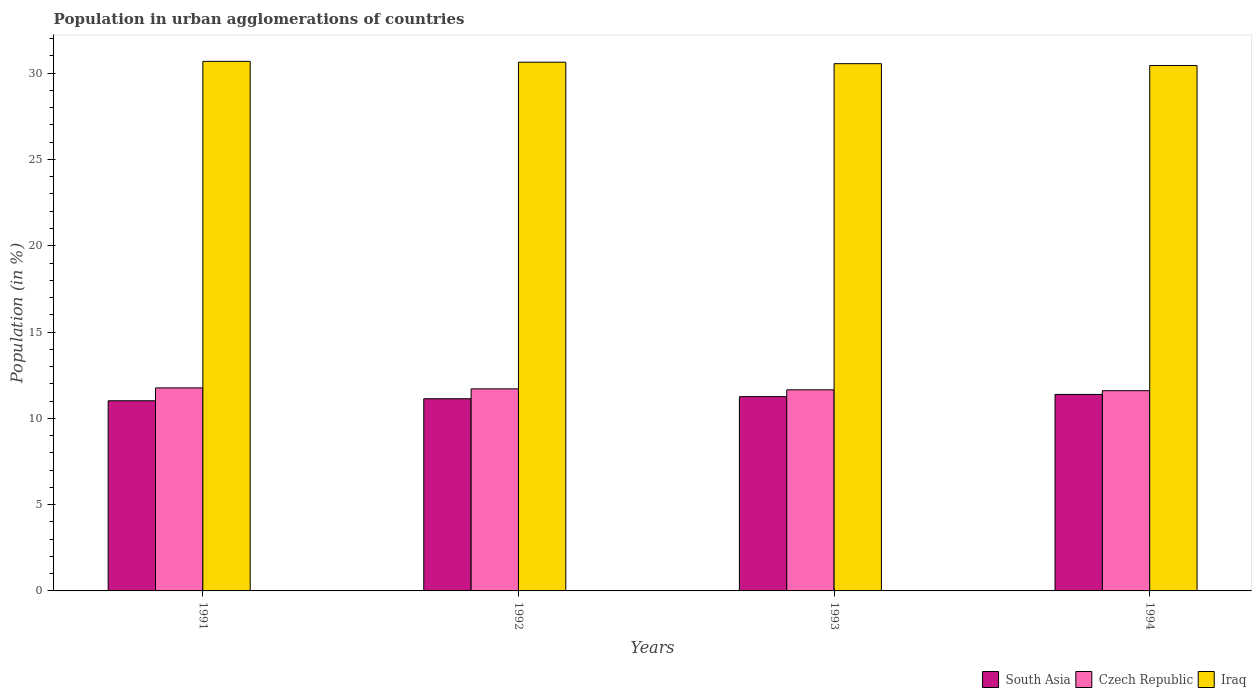How many different coloured bars are there?
Give a very brief answer. 3. How many groups of bars are there?
Offer a terse response. 4. Are the number of bars on each tick of the X-axis equal?
Give a very brief answer. Yes. How many bars are there on the 3rd tick from the right?
Your answer should be compact. 3. What is the percentage of population in urban agglomerations in Czech Republic in 1994?
Keep it short and to the point. 11.6. Across all years, what is the maximum percentage of population in urban agglomerations in Iraq?
Your answer should be compact. 30.68. Across all years, what is the minimum percentage of population in urban agglomerations in Iraq?
Provide a short and direct response. 30.44. In which year was the percentage of population in urban agglomerations in Czech Republic maximum?
Offer a terse response. 1991. In which year was the percentage of population in urban agglomerations in Iraq minimum?
Offer a terse response. 1994. What is the total percentage of population in urban agglomerations in Czech Republic in the graph?
Provide a succinct answer. 46.72. What is the difference between the percentage of population in urban agglomerations in South Asia in 1993 and that in 1994?
Make the answer very short. -0.13. What is the difference between the percentage of population in urban agglomerations in South Asia in 1993 and the percentage of population in urban agglomerations in Iraq in 1994?
Offer a terse response. -19.19. What is the average percentage of population in urban agglomerations in Czech Republic per year?
Ensure brevity in your answer.  11.68. In the year 1994, what is the difference between the percentage of population in urban agglomerations in South Asia and percentage of population in urban agglomerations in Iraq?
Offer a very short reply. -19.06. What is the ratio of the percentage of population in urban agglomerations in Iraq in 1991 to that in 1992?
Your answer should be very brief. 1. Is the percentage of population in urban agglomerations in South Asia in 1993 less than that in 1994?
Your response must be concise. Yes. What is the difference between the highest and the second highest percentage of population in urban agglomerations in South Asia?
Ensure brevity in your answer.  0.13. What is the difference between the highest and the lowest percentage of population in urban agglomerations in South Asia?
Your response must be concise. 0.37. In how many years, is the percentage of population in urban agglomerations in Iraq greater than the average percentage of population in urban agglomerations in Iraq taken over all years?
Keep it short and to the point. 2. What does the 3rd bar from the left in 1993 represents?
Offer a very short reply. Iraq. What does the 1st bar from the right in 1991 represents?
Your response must be concise. Iraq. Is it the case that in every year, the sum of the percentage of population in urban agglomerations in Iraq and percentage of population in urban agglomerations in Czech Republic is greater than the percentage of population in urban agglomerations in South Asia?
Provide a short and direct response. Yes. How many bars are there?
Ensure brevity in your answer.  12. Are all the bars in the graph horizontal?
Your answer should be compact. No. What is the difference between two consecutive major ticks on the Y-axis?
Your response must be concise. 5. Are the values on the major ticks of Y-axis written in scientific E-notation?
Keep it short and to the point. No. Does the graph contain grids?
Keep it short and to the point. No. Where does the legend appear in the graph?
Offer a terse response. Bottom right. How are the legend labels stacked?
Keep it short and to the point. Horizontal. What is the title of the graph?
Keep it short and to the point. Population in urban agglomerations of countries. Does "United Kingdom" appear as one of the legend labels in the graph?
Offer a very short reply. No. What is the label or title of the X-axis?
Ensure brevity in your answer.  Years. What is the label or title of the Y-axis?
Offer a very short reply. Population (in %). What is the Population (in %) of South Asia in 1991?
Offer a very short reply. 11.02. What is the Population (in %) in Czech Republic in 1991?
Provide a succinct answer. 11.76. What is the Population (in %) in Iraq in 1991?
Your response must be concise. 30.68. What is the Population (in %) of South Asia in 1992?
Your answer should be very brief. 11.13. What is the Population (in %) of Czech Republic in 1992?
Ensure brevity in your answer.  11.71. What is the Population (in %) in Iraq in 1992?
Give a very brief answer. 30.64. What is the Population (in %) in South Asia in 1993?
Offer a very short reply. 11.26. What is the Population (in %) of Czech Republic in 1993?
Provide a short and direct response. 11.65. What is the Population (in %) of Iraq in 1993?
Your answer should be very brief. 30.55. What is the Population (in %) of South Asia in 1994?
Offer a terse response. 11.39. What is the Population (in %) of Czech Republic in 1994?
Your response must be concise. 11.6. What is the Population (in %) of Iraq in 1994?
Keep it short and to the point. 30.44. Across all years, what is the maximum Population (in %) of South Asia?
Offer a terse response. 11.39. Across all years, what is the maximum Population (in %) in Czech Republic?
Offer a terse response. 11.76. Across all years, what is the maximum Population (in %) in Iraq?
Your answer should be compact. 30.68. Across all years, what is the minimum Population (in %) of South Asia?
Provide a short and direct response. 11.02. Across all years, what is the minimum Population (in %) in Czech Republic?
Your answer should be compact. 11.6. Across all years, what is the minimum Population (in %) of Iraq?
Offer a very short reply. 30.44. What is the total Population (in %) of South Asia in the graph?
Offer a terse response. 44.8. What is the total Population (in %) in Czech Republic in the graph?
Give a very brief answer. 46.72. What is the total Population (in %) of Iraq in the graph?
Your answer should be compact. 122.31. What is the difference between the Population (in %) in South Asia in 1991 and that in 1992?
Give a very brief answer. -0.12. What is the difference between the Population (in %) in Czech Republic in 1991 and that in 1992?
Offer a very short reply. 0.06. What is the difference between the Population (in %) of Iraq in 1991 and that in 1992?
Ensure brevity in your answer.  0.05. What is the difference between the Population (in %) of South Asia in 1991 and that in 1993?
Make the answer very short. -0.24. What is the difference between the Population (in %) in Czech Republic in 1991 and that in 1993?
Your answer should be very brief. 0.11. What is the difference between the Population (in %) of Iraq in 1991 and that in 1993?
Offer a terse response. 0.13. What is the difference between the Population (in %) of South Asia in 1991 and that in 1994?
Keep it short and to the point. -0.37. What is the difference between the Population (in %) of Czech Republic in 1991 and that in 1994?
Ensure brevity in your answer.  0.16. What is the difference between the Population (in %) in Iraq in 1991 and that in 1994?
Offer a terse response. 0.24. What is the difference between the Population (in %) of South Asia in 1992 and that in 1993?
Provide a short and direct response. -0.12. What is the difference between the Population (in %) in Czech Republic in 1992 and that in 1993?
Offer a terse response. 0.06. What is the difference between the Population (in %) in Iraq in 1992 and that in 1993?
Offer a very short reply. 0.09. What is the difference between the Population (in %) of South Asia in 1992 and that in 1994?
Provide a short and direct response. -0.25. What is the difference between the Population (in %) in Czech Republic in 1992 and that in 1994?
Ensure brevity in your answer.  0.1. What is the difference between the Population (in %) in Iraq in 1992 and that in 1994?
Provide a succinct answer. 0.19. What is the difference between the Population (in %) of South Asia in 1993 and that in 1994?
Your answer should be compact. -0.13. What is the difference between the Population (in %) in Czech Republic in 1993 and that in 1994?
Keep it short and to the point. 0.05. What is the difference between the Population (in %) of Iraq in 1993 and that in 1994?
Make the answer very short. 0.11. What is the difference between the Population (in %) in South Asia in 1991 and the Population (in %) in Czech Republic in 1992?
Keep it short and to the point. -0.69. What is the difference between the Population (in %) of South Asia in 1991 and the Population (in %) of Iraq in 1992?
Give a very brief answer. -19.62. What is the difference between the Population (in %) in Czech Republic in 1991 and the Population (in %) in Iraq in 1992?
Provide a succinct answer. -18.87. What is the difference between the Population (in %) in South Asia in 1991 and the Population (in %) in Czech Republic in 1993?
Provide a succinct answer. -0.63. What is the difference between the Population (in %) of South Asia in 1991 and the Population (in %) of Iraq in 1993?
Provide a short and direct response. -19.53. What is the difference between the Population (in %) in Czech Republic in 1991 and the Population (in %) in Iraq in 1993?
Offer a terse response. -18.79. What is the difference between the Population (in %) in South Asia in 1991 and the Population (in %) in Czech Republic in 1994?
Offer a very short reply. -0.58. What is the difference between the Population (in %) in South Asia in 1991 and the Population (in %) in Iraq in 1994?
Keep it short and to the point. -19.42. What is the difference between the Population (in %) in Czech Republic in 1991 and the Population (in %) in Iraq in 1994?
Ensure brevity in your answer.  -18.68. What is the difference between the Population (in %) of South Asia in 1992 and the Population (in %) of Czech Republic in 1993?
Keep it short and to the point. -0.52. What is the difference between the Population (in %) in South Asia in 1992 and the Population (in %) in Iraq in 1993?
Provide a short and direct response. -19.41. What is the difference between the Population (in %) of Czech Republic in 1992 and the Population (in %) of Iraq in 1993?
Provide a succinct answer. -18.84. What is the difference between the Population (in %) in South Asia in 1992 and the Population (in %) in Czech Republic in 1994?
Keep it short and to the point. -0.47. What is the difference between the Population (in %) in South Asia in 1992 and the Population (in %) in Iraq in 1994?
Offer a terse response. -19.31. What is the difference between the Population (in %) in Czech Republic in 1992 and the Population (in %) in Iraq in 1994?
Give a very brief answer. -18.73. What is the difference between the Population (in %) in South Asia in 1993 and the Population (in %) in Czech Republic in 1994?
Ensure brevity in your answer.  -0.35. What is the difference between the Population (in %) of South Asia in 1993 and the Population (in %) of Iraq in 1994?
Make the answer very short. -19.19. What is the difference between the Population (in %) of Czech Republic in 1993 and the Population (in %) of Iraq in 1994?
Provide a short and direct response. -18.79. What is the average Population (in %) of South Asia per year?
Your answer should be very brief. 11.2. What is the average Population (in %) in Czech Republic per year?
Provide a succinct answer. 11.68. What is the average Population (in %) of Iraq per year?
Your response must be concise. 30.58. In the year 1991, what is the difference between the Population (in %) in South Asia and Population (in %) in Czech Republic?
Provide a short and direct response. -0.75. In the year 1991, what is the difference between the Population (in %) of South Asia and Population (in %) of Iraq?
Offer a terse response. -19.67. In the year 1991, what is the difference between the Population (in %) of Czech Republic and Population (in %) of Iraq?
Your response must be concise. -18.92. In the year 1992, what is the difference between the Population (in %) of South Asia and Population (in %) of Czech Republic?
Give a very brief answer. -0.57. In the year 1992, what is the difference between the Population (in %) in South Asia and Population (in %) in Iraq?
Offer a very short reply. -19.5. In the year 1992, what is the difference between the Population (in %) in Czech Republic and Population (in %) in Iraq?
Your response must be concise. -18.93. In the year 1993, what is the difference between the Population (in %) of South Asia and Population (in %) of Czech Republic?
Keep it short and to the point. -0.39. In the year 1993, what is the difference between the Population (in %) of South Asia and Population (in %) of Iraq?
Your answer should be compact. -19.29. In the year 1993, what is the difference between the Population (in %) of Czech Republic and Population (in %) of Iraq?
Provide a short and direct response. -18.9. In the year 1994, what is the difference between the Population (in %) of South Asia and Population (in %) of Czech Republic?
Provide a succinct answer. -0.22. In the year 1994, what is the difference between the Population (in %) of South Asia and Population (in %) of Iraq?
Make the answer very short. -19.06. In the year 1994, what is the difference between the Population (in %) of Czech Republic and Population (in %) of Iraq?
Make the answer very short. -18.84. What is the ratio of the Population (in %) of Czech Republic in 1991 to that in 1992?
Keep it short and to the point. 1. What is the ratio of the Population (in %) in Iraq in 1991 to that in 1992?
Give a very brief answer. 1. What is the ratio of the Population (in %) in South Asia in 1991 to that in 1993?
Provide a short and direct response. 0.98. What is the ratio of the Population (in %) in Czech Republic in 1991 to that in 1993?
Provide a short and direct response. 1.01. What is the ratio of the Population (in %) in South Asia in 1991 to that in 1994?
Ensure brevity in your answer.  0.97. What is the ratio of the Population (in %) in Czech Republic in 1991 to that in 1994?
Give a very brief answer. 1.01. What is the ratio of the Population (in %) in Iraq in 1991 to that in 1994?
Your response must be concise. 1.01. What is the ratio of the Population (in %) of Czech Republic in 1992 to that in 1993?
Provide a succinct answer. 1. What is the ratio of the Population (in %) of South Asia in 1992 to that in 1994?
Ensure brevity in your answer.  0.98. What is the ratio of the Population (in %) of Iraq in 1992 to that in 1994?
Provide a succinct answer. 1.01. What is the ratio of the Population (in %) of South Asia in 1993 to that in 1994?
Make the answer very short. 0.99. What is the ratio of the Population (in %) in Iraq in 1993 to that in 1994?
Your response must be concise. 1. What is the difference between the highest and the second highest Population (in %) in South Asia?
Keep it short and to the point. 0.13. What is the difference between the highest and the second highest Population (in %) in Czech Republic?
Provide a succinct answer. 0.06. What is the difference between the highest and the second highest Population (in %) in Iraq?
Offer a very short reply. 0.05. What is the difference between the highest and the lowest Population (in %) of South Asia?
Your answer should be compact. 0.37. What is the difference between the highest and the lowest Population (in %) in Czech Republic?
Provide a succinct answer. 0.16. What is the difference between the highest and the lowest Population (in %) in Iraq?
Your answer should be very brief. 0.24. 